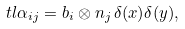<formula> <loc_0><loc_0><loc_500><loc_500>\ t l \alpha _ { i j } = b _ { i } \otimes n _ { j } \, \delta ( x ) \delta ( y ) ,</formula> 